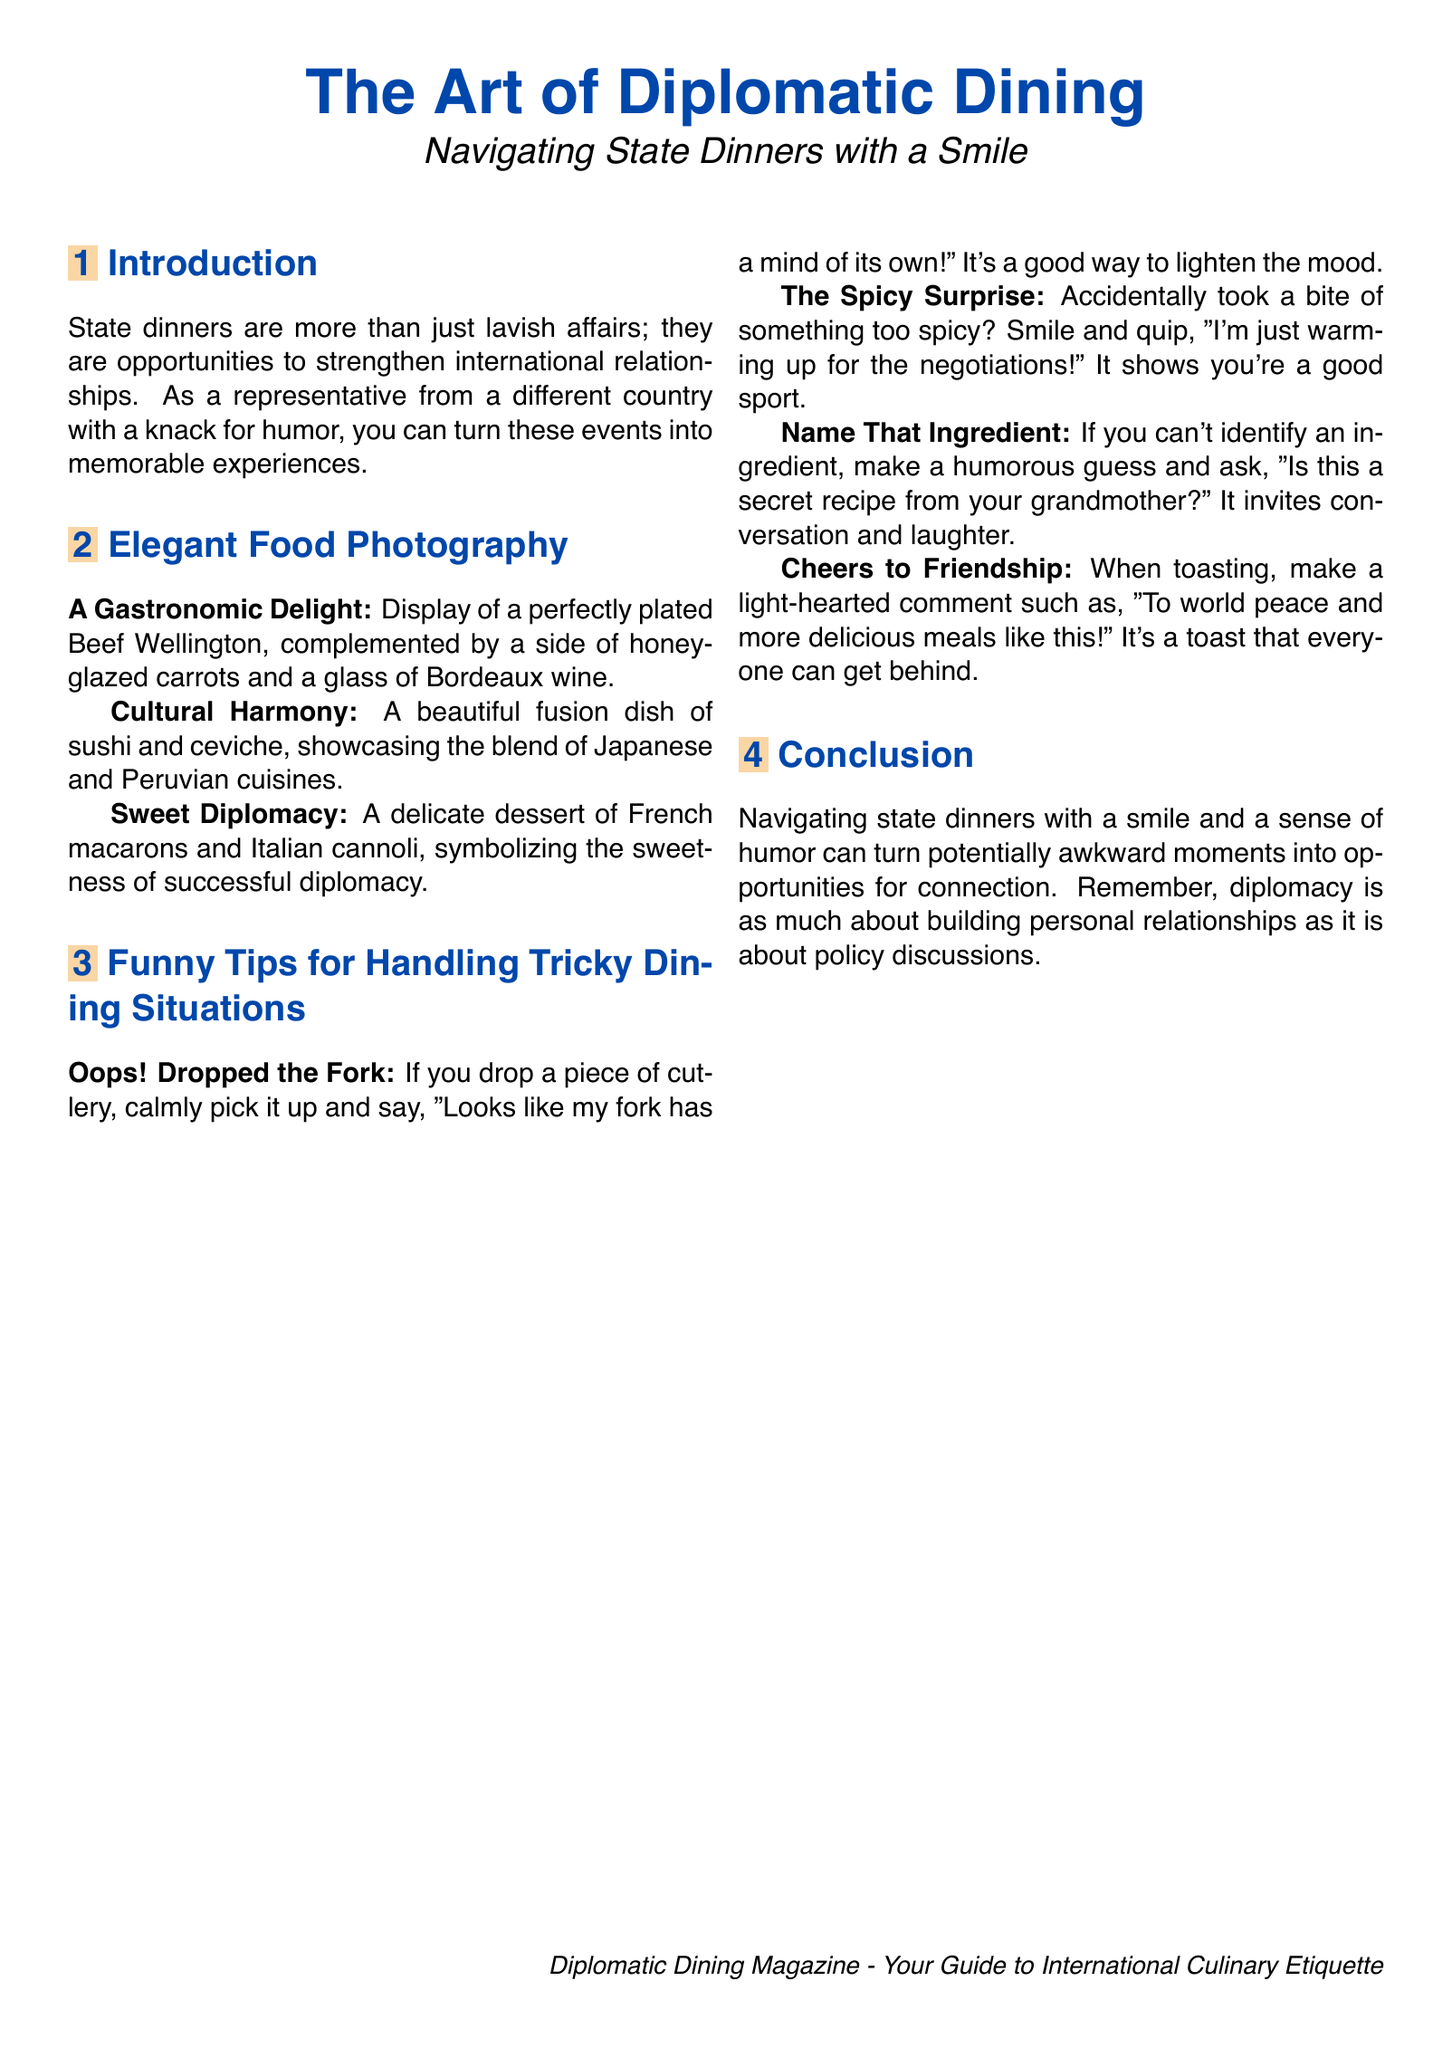What is the title of the magazine? The title of the magazine is presented at the top of the document.
Answer: The Art of Diplomatic Dining What dish is displayed as a gastronomic delight? The document explicitly mentions a perfectly plated dish as a gastronomic delight.
Answer: Beef Wellington What cultural fusion dish is showcased? The document refers to a dish that combines two different cuisines.
Answer: Sushi and ceviche What humorous excuse is suggested if you drop a fork? The document provides a light-hearted response for this situation.
Answer: "Looks like my fork has a mind of its own!" What should you say when you accidentally eat something spicy? The document suggests a funny comment for this scenario.
Answer: "I'm just warming up for the negotiations!" What is the suggested light-hearted toast? The toast mentioned in the document emphasizes a positive sentiment.
Answer: "To world peace and more delicious meals like this!" How many tips for handling tricky dining situations are provided? The document includes a specific number of tips listed in the section.
Answer: Four What is the main theme of the article? The overall focus of the article is indicated in the introductory section.
Answer: Navigating state dinners with a smile What type of magazine is this document categorized as? The introductory part labels the nature of the publication.
Answer: Diplomatic Dining Magazine 